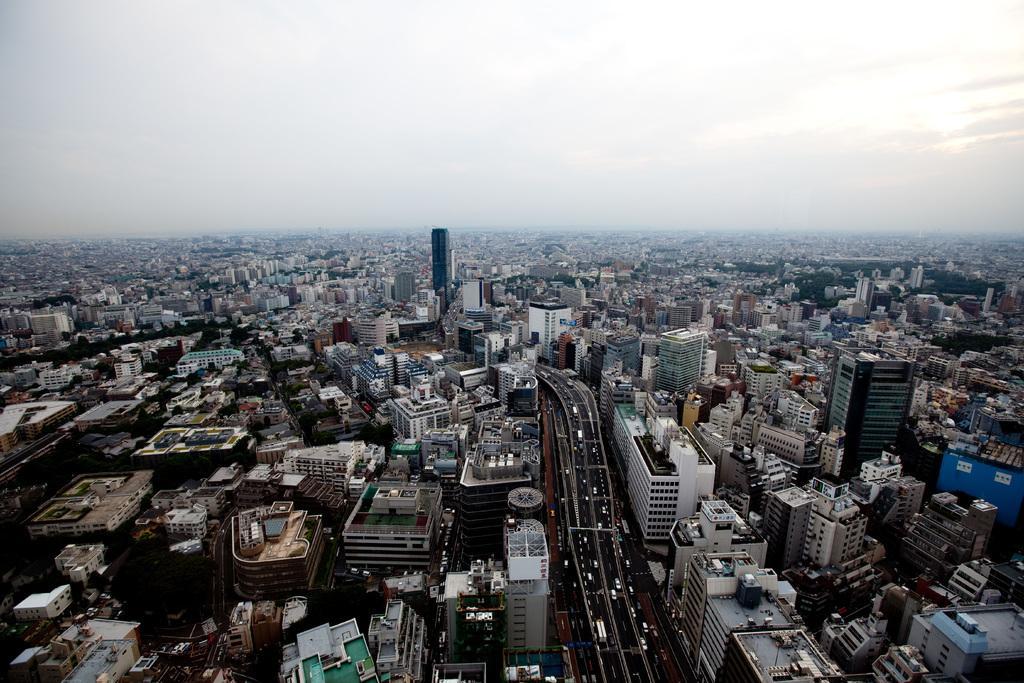Please provide a concise description of this image. In this image, we can see so many buildings, roads, vehicles. Top of the image, there is a sky. 